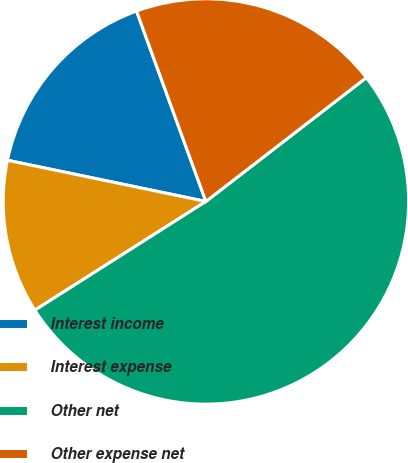Convert chart. <chart><loc_0><loc_0><loc_500><loc_500><pie_chart><fcel>Interest income<fcel>Interest expense<fcel>Other net<fcel>Other expense net<nl><fcel>16.18%<fcel>12.27%<fcel>51.45%<fcel>20.1%<nl></chart> 